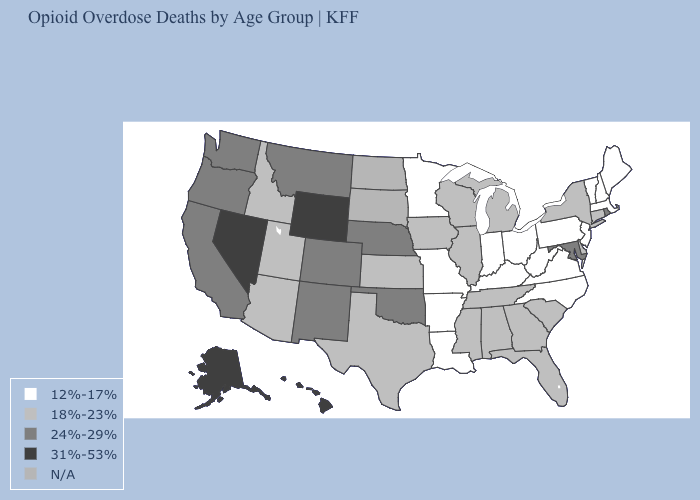Name the states that have a value in the range 24%-29%?
Quick response, please. California, Colorado, Maryland, Montana, Nebraska, New Mexico, Oklahoma, Oregon, Rhode Island, Washington. What is the lowest value in states that border Maine?
Quick response, please. 12%-17%. What is the value of Alabama?
Keep it brief. 18%-23%. What is the value of Indiana?
Give a very brief answer. 12%-17%. What is the value of Alaska?
Answer briefly. 31%-53%. Name the states that have a value in the range 18%-23%?
Concise answer only. Alabama, Arizona, Connecticut, Delaware, Florida, Georgia, Idaho, Illinois, Iowa, Kansas, Michigan, Mississippi, New York, South Carolina, Tennessee, Texas, Utah, Wisconsin. What is the highest value in states that border North Carolina?
Be succinct. 18%-23%. Which states have the highest value in the USA?
Short answer required. Alaska, Hawaii, Nevada, Wyoming. Among the states that border South Dakota , which have the lowest value?
Keep it brief. Minnesota. Name the states that have a value in the range N/A?
Be succinct. North Dakota, South Dakota. Name the states that have a value in the range N/A?
Be succinct. North Dakota, South Dakota. What is the lowest value in the USA?
Answer briefly. 12%-17%. Which states have the highest value in the USA?
Answer briefly. Alaska, Hawaii, Nevada, Wyoming. Does Alabama have the lowest value in the South?
Answer briefly. No. What is the value of Delaware?
Give a very brief answer. 18%-23%. 